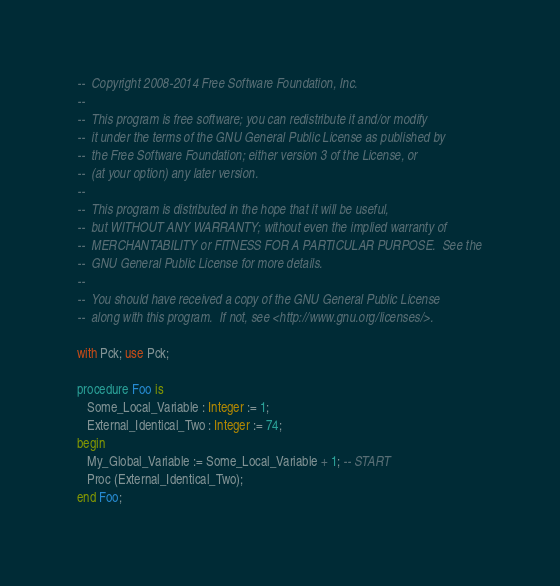<code> <loc_0><loc_0><loc_500><loc_500><_Ada_>--  Copyright 2008-2014 Free Software Foundation, Inc.
--
--  This program is free software; you can redistribute it and/or modify
--  it under the terms of the GNU General Public License as published by
--  the Free Software Foundation; either version 3 of the License, or
--  (at your option) any later version.
--
--  This program is distributed in the hope that it will be useful,
--  but WITHOUT ANY WARRANTY; without even the implied warranty of
--  MERCHANTABILITY or FITNESS FOR A PARTICULAR PURPOSE.  See the
--  GNU General Public License for more details.
--
--  You should have received a copy of the GNU General Public License
--  along with this program.  If not, see <http://www.gnu.org/licenses/>.

with Pck; use Pck;

procedure Foo is
   Some_Local_Variable : Integer := 1;
   External_Identical_Two : Integer := 74;
begin
   My_Global_Variable := Some_Local_Variable + 1; -- START
   Proc (External_Identical_Two);
end Foo;

</code> 